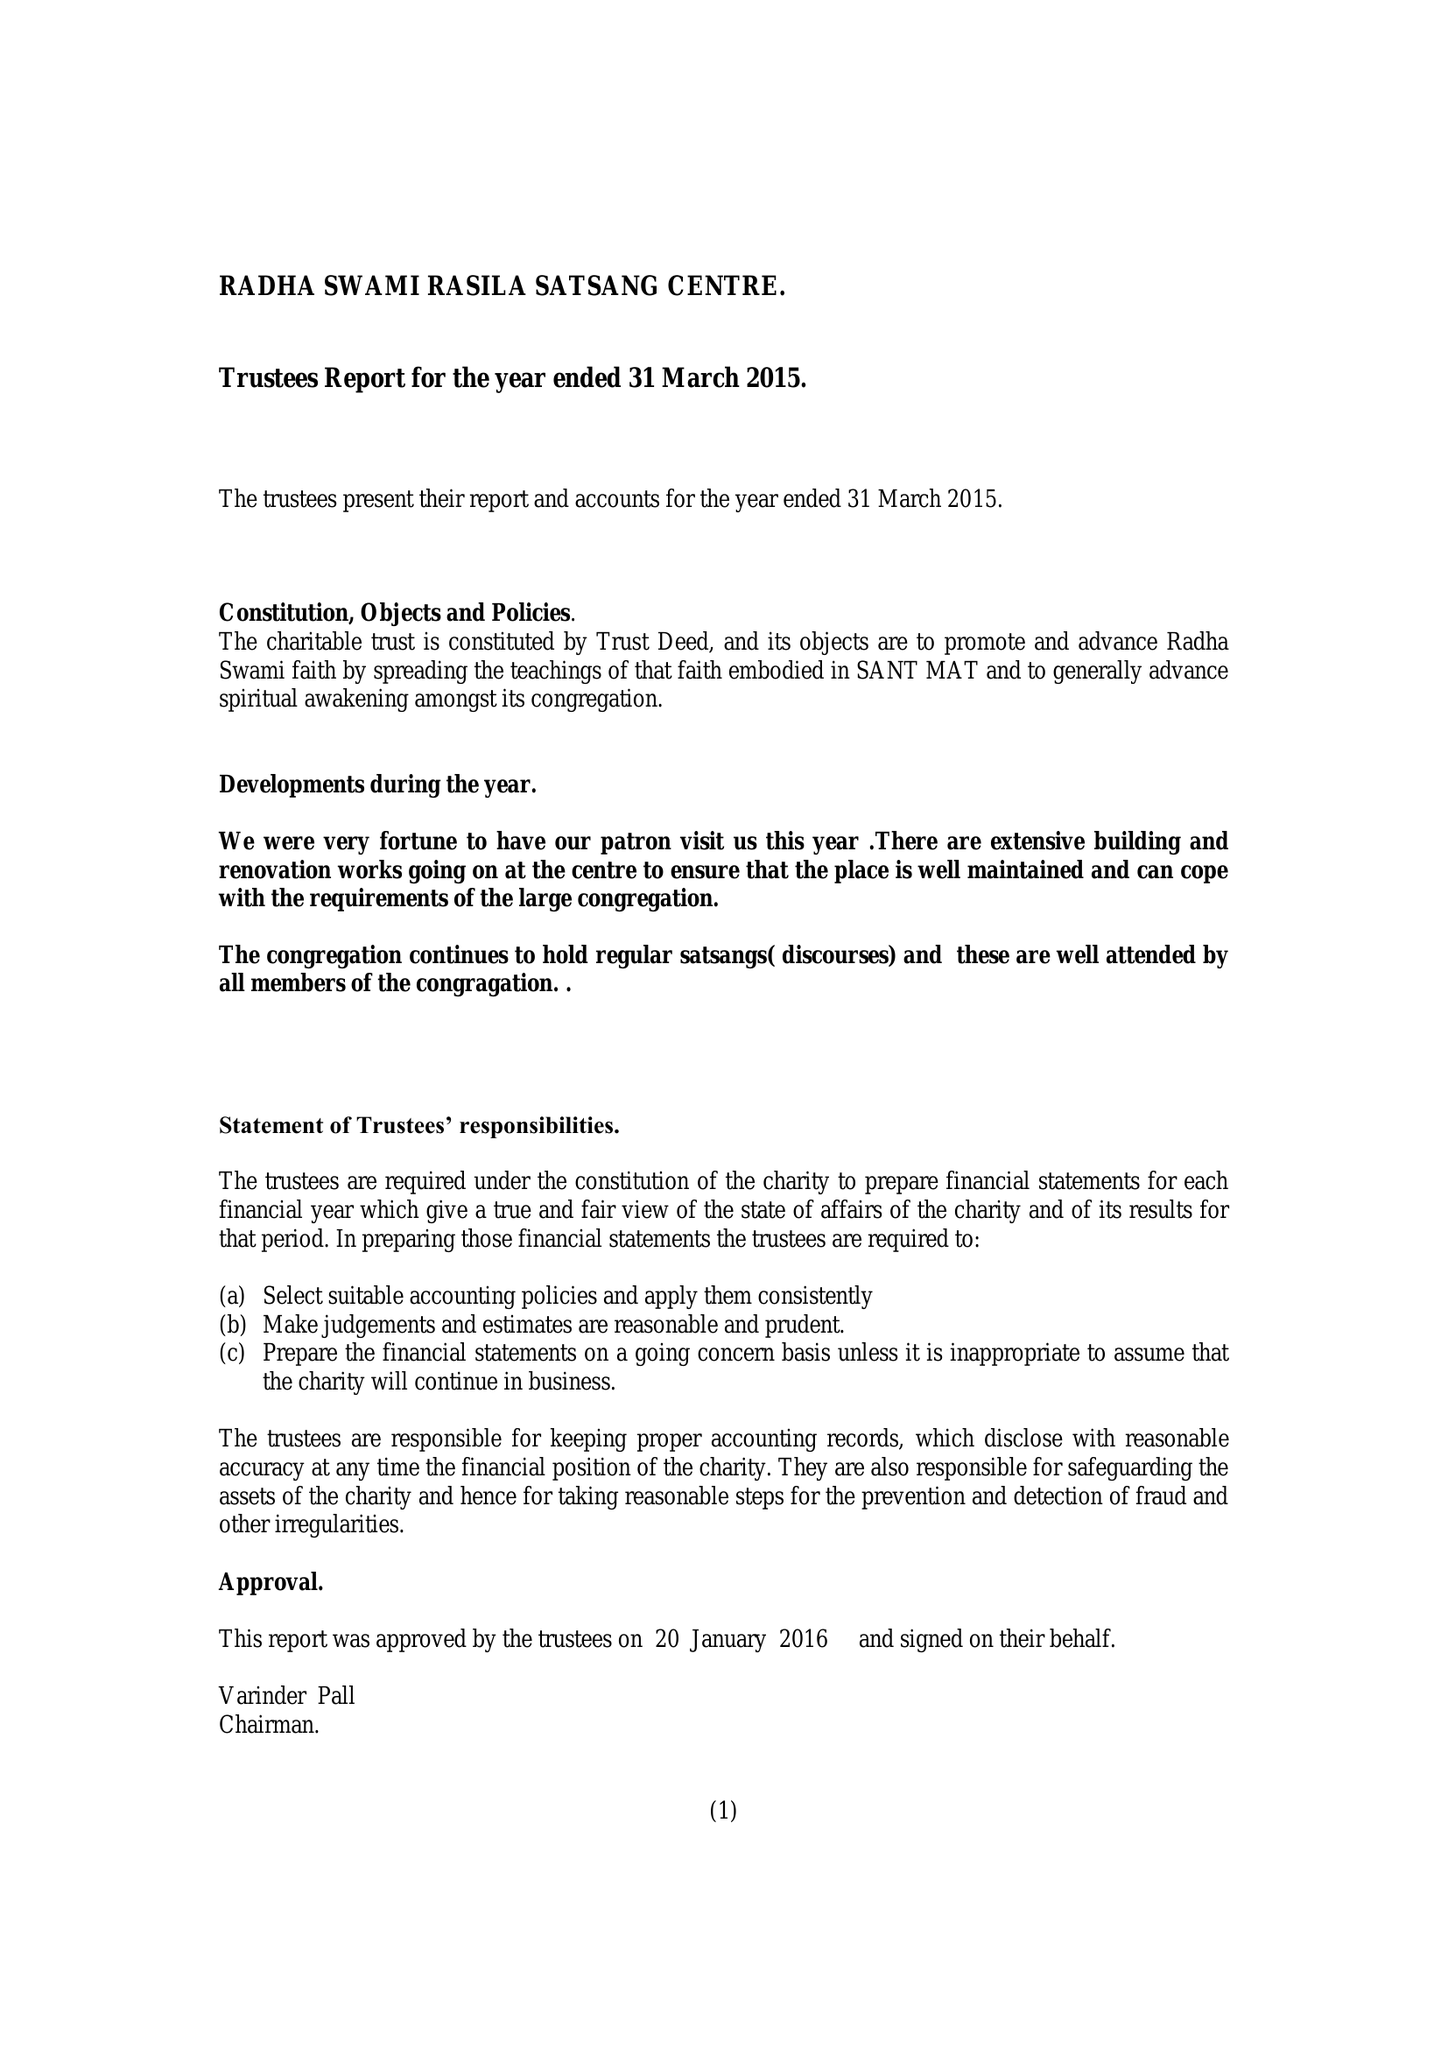What is the value for the address__postcode?
Answer the question using a single word or phrase. B18 5HS 